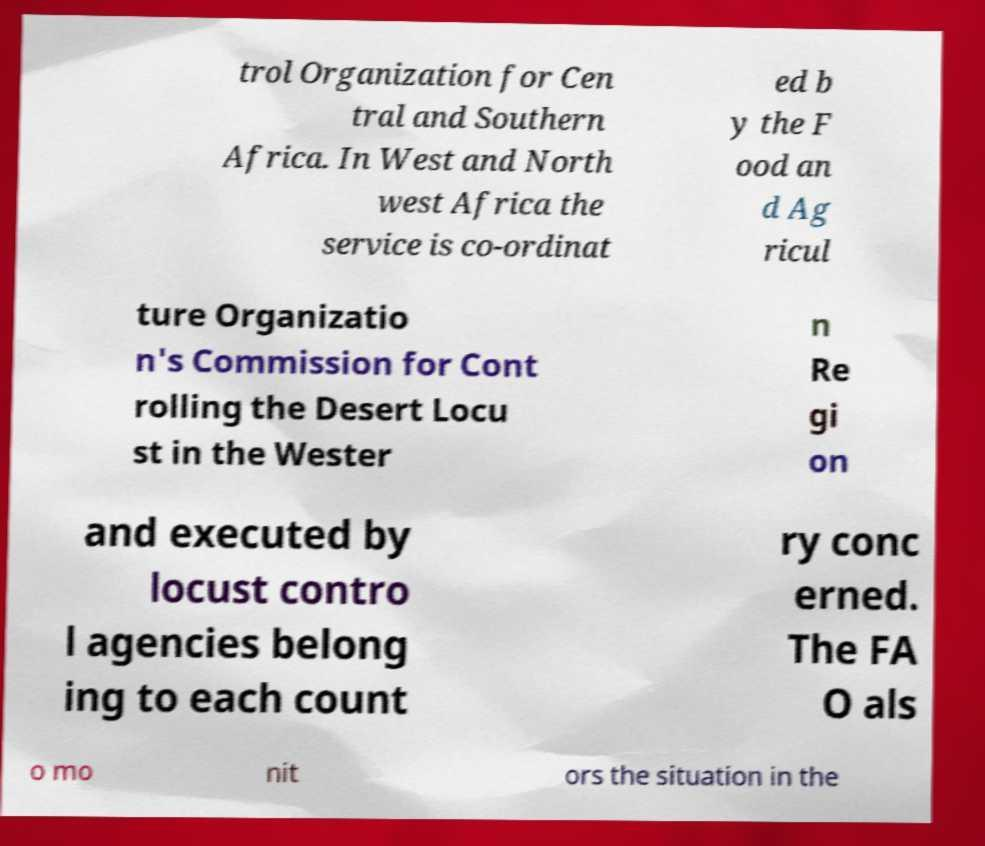I need the written content from this picture converted into text. Can you do that? trol Organization for Cen tral and Southern Africa. In West and North west Africa the service is co-ordinat ed b y the F ood an d Ag ricul ture Organizatio n's Commission for Cont rolling the Desert Locu st in the Wester n Re gi on and executed by locust contro l agencies belong ing to each count ry conc erned. The FA O als o mo nit ors the situation in the 